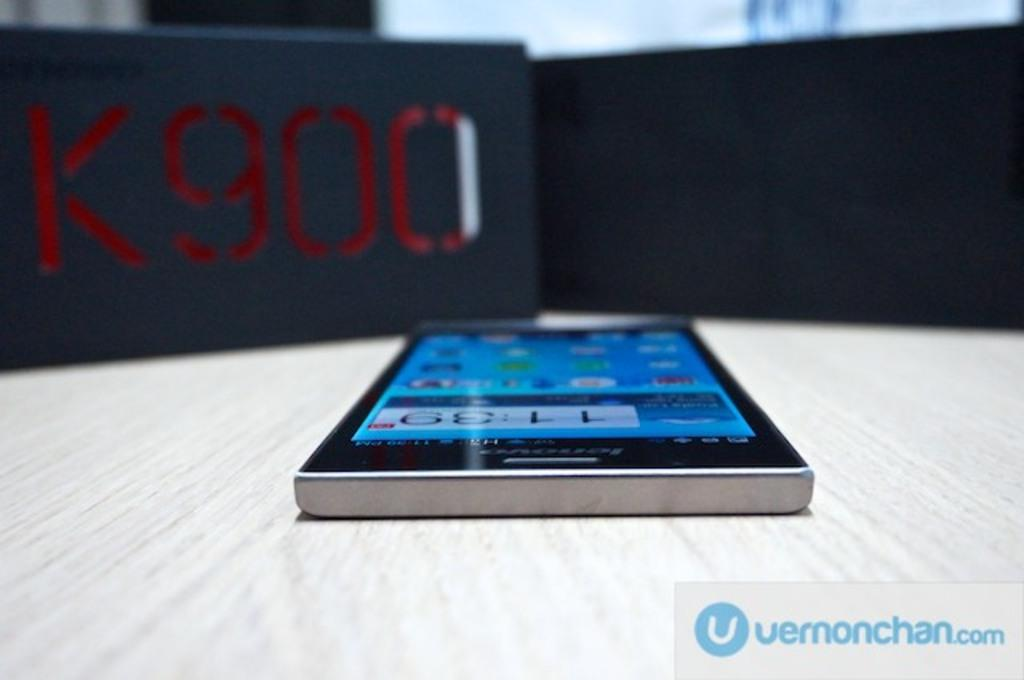<image>
Offer a succinct explanation of the picture presented. a phone near a black background that says K900 